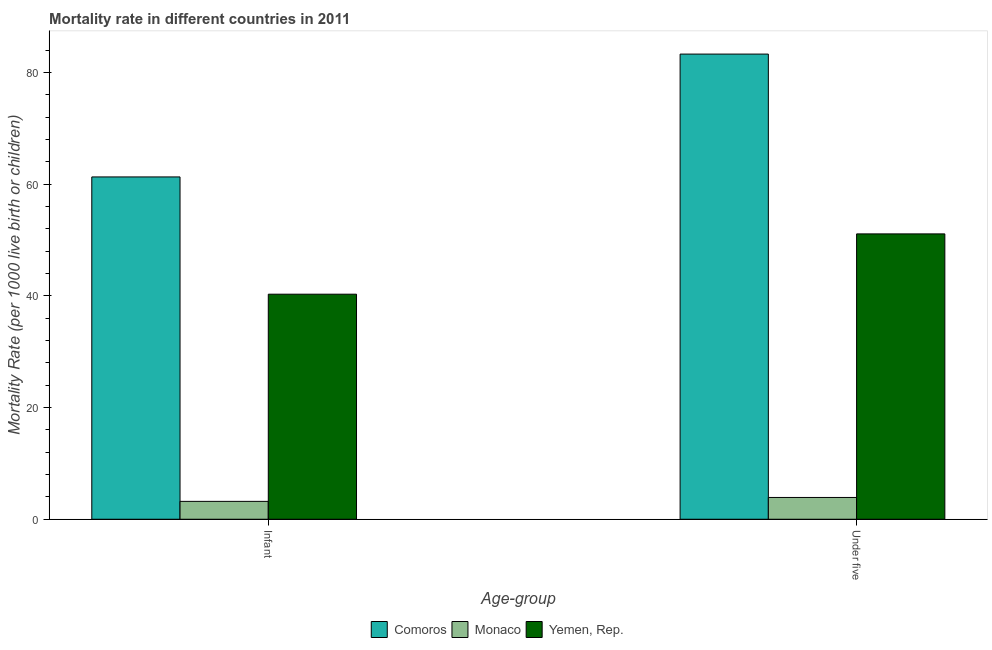How many different coloured bars are there?
Your answer should be compact. 3. How many bars are there on the 1st tick from the left?
Provide a succinct answer. 3. How many bars are there on the 2nd tick from the right?
Give a very brief answer. 3. What is the label of the 2nd group of bars from the left?
Your response must be concise. Under five. What is the infant mortality rate in Monaco?
Give a very brief answer. 3.2. Across all countries, what is the maximum infant mortality rate?
Keep it short and to the point. 61.3. In which country was the infant mortality rate maximum?
Keep it short and to the point. Comoros. In which country was the under-5 mortality rate minimum?
Your response must be concise. Monaco. What is the total under-5 mortality rate in the graph?
Make the answer very short. 138.3. What is the difference between the infant mortality rate in Monaco and that in Yemen, Rep.?
Your answer should be very brief. -37.1. What is the difference between the under-5 mortality rate in Yemen, Rep. and the infant mortality rate in Monaco?
Your answer should be very brief. 47.9. What is the average infant mortality rate per country?
Provide a succinct answer. 34.93. What is the difference between the infant mortality rate and under-5 mortality rate in Yemen, Rep.?
Your response must be concise. -10.8. What is the ratio of the infant mortality rate in Monaco to that in Yemen, Rep.?
Keep it short and to the point. 0.08. In how many countries, is the infant mortality rate greater than the average infant mortality rate taken over all countries?
Your answer should be very brief. 2. What does the 3rd bar from the left in Infant represents?
Give a very brief answer. Yemen, Rep. What does the 3rd bar from the right in Infant represents?
Your answer should be compact. Comoros. Are all the bars in the graph horizontal?
Offer a very short reply. No. How many countries are there in the graph?
Ensure brevity in your answer.  3. Does the graph contain any zero values?
Make the answer very short. No. Does the graph contain grids?
Give a very brief answer. No. How are the legend labels stacked?
Give a very brief answer. Horizontal. What is the title of the graph?
Give a very brief answer. Mortality rate in different countries in 2011. What is the label or title of the X-axis?
Give a very brief answer. Age-group. What is the label or title of the Y-axis?
Keep it short and to the point. Mortality Rate (per 1000 live birth or children). What is the Mortality Rate (per 1000 live birth or children) in Comoros in Infant?
Your answer should be compact. 61.3. What is the Mortality Rate (per 1000 live birth or children) in Monaco in Infant?
Offer a very short reply. 3.2. What is the Mortality Rate (per 1000 live birth or children) in Yemen, Rep. in Infant?
Give a very brief answer. 40.3. What is the Mortality Rate (per 1000 live birth or children) in Comoros in Under five?
Provide a succinct answer. 83.3. What is the Mortality Rate (per 1000 live birth or children) of Yemen, Rep. in Under five?
Offer a terse response. 51.1. Across all Age-group, what is the maximum Mortality Rate (per 1000 live birth or children) in Comoros?
Your response must be concise. 83.3. Across all Age-group, what is the maximum Mortality Rate (per 1000 live birth or children) in Monaco?
Offer a very short reply. 3.9. Across all Age-group, what is the maximum Mortality Rate (per 1000 live birth or children) in Yemen, Rep.?
Provide a succinct answer. 51.1. Across all Age-group, what is the minimum Mortality Rate (per 1000 live birth or children) in Comoros?
Provide a succinct answer. 61.3. Across all Age-group, what is the minimum Mortality Rate (per 1000 live birth or children) in Monaco?
Your answer should be very brief. 3.2. Across all Age-group, what is the minimum Mortality Rate (per 1000 live birth or children) in Yemen, Rep.?
Keep it short and to the point. 40.3. What is the total Mortality Rate (per 1000 live birth or children) of Comoros in the graph?
Your answer should be compact. 144.6. What is the total Mortality Rate (per 1000 live birth or children) in Yemen, Rep. in the graph?
Keep it short and to the point. 91.4. What is the difference between the Mortality Rate (per 1000 live birth or children) of Comoros in Infant and that in Under five?
Give a very brief answer. -22. What is the difference between the Mortality Rate (per 1000 live birth or children) in Yemen, Rep. in Infant and that in Under five?
Offer a very short reply. -10.8. What is the difference between the Mortality Rate (per 1000 live birth or children) in Comoros in Infant and the Mortality Rate (per 1000 live birth or children) in Monaco in Under five?
Your response must be concise. 57.4. What is the difference between the Mortality Rate (per 1000 live birth or children) in Monaco in Infant and the Mortality Rate (per 1000 live birth or children) in Yemen, Rep. in Under five?
Offer a terse response. -47.9. What is the average Mortality Rate (per 1000 live birth or children) in Comoros per Age-group?
Make the answer very short. 72.3. What is the average Mortality Rate (per 1000 live birth or children) in Monaco per Age-group?
Keep it short and to the point. 3.55. What is the average Mortality Rate (per 1000 live birth or children) in Yemen, Rep. per Age-group?
Offer a very short reply. 45.7. What is the difference between the Mortality Rate (per 1000 live birth or children) of Comoros and Mortality Rate (per 1000 live birth or children) of Monaco in Infant?
Offer a terse response. 58.1. What is the difference between the Mortality Rate (per 1000 live birth or children) of Comoros and Mortality Rate (per 1000 live birth or children) of Yemen, Rep. in Infant?
Offer a terse response. 21. What is the difference between the Mortality Rate (per 1000 live birth or children) in Monaco and Mortality Rate (per 1000 live birth or children) in Yemen, Rep. in Infant?
Offer a terse response. -37.1. What is the difference between the Mortality Rate (per 1000 live birth or children) in Comoros and Mortality Rate (per 1000 live birth or children) in Monaco in Under five?
Your answer should be compact. 79.4. What is the difference between the Mortality Rate (per 1000 live birth or children) of Comoros and Mortality Rate (per 1000 live birth or children) of Yemen, Rep. in Under five?
Make the answer very short. 32.2. What is the difference between the Mortality Rate (per 1000 live birth or children) in Monaco and Mortality Rate (per 1000 live birth or children) in Yemen, Rep. in Under five?
Your answer should be compact. -47.2. What is the ratio of the Mortality Rate (per 1000 live birth or children) in Comoros in Infant to that in Under five?
Your answer should be very brief. 0.74. What is the ratio of the Mortality Rate (per 1000 live birth or children) of Monaco in Infant to that in Under five?
Offer a terse response. 0.82. What is the ratio of the Mortality Rate (per 1000 live birth or children) of Yemen, Rep. in Infant to that in Under five?
Make the answer very short. 0.79. What is the difference between the highest and the second highest Mortality Rate (per 1000 live birth or children) in Comoros?
Give a very brief answer. 22. What is the difference between the highest and the second highest Mortality Rate (per 1000 live birth or children) of Monaco?
Your answer should be compact. 0.7. What is the difference between the highest and the lowest Mortality Rate (per 1000 live birth or children) of Comoros?
Provide a short and direct response. 22. 